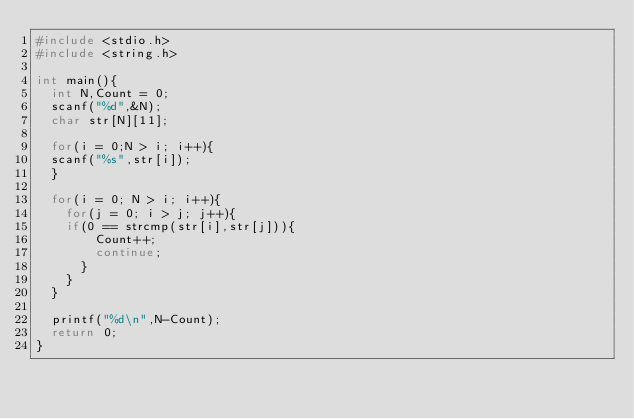Convert code to text. <code><loc_0><loc_0><loc_500><loc_500><_C_>#include <stdio.h>
#include <string.h>

int main(){
  int N,Count = 0;
  scanf("%d",&N);
  char str[N][11];
  
  for(i = 0;N > i; i++){
	scanf("%s",str[i]);
  }
  
  for(i = 0; N > i; i++){
    for(j = 0; i > j; j++){
	  if(0 == strcmp(str[i],str[j])){
        Count++;
        continue;
      }
    }
  }
  
  printf("%d\n",N-Count);
  return 0;
}</code> 